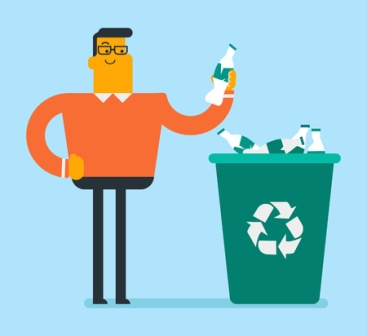Imagine an advertising slogan for this image. “Recycle Today for a Greener Tomorrow.” 